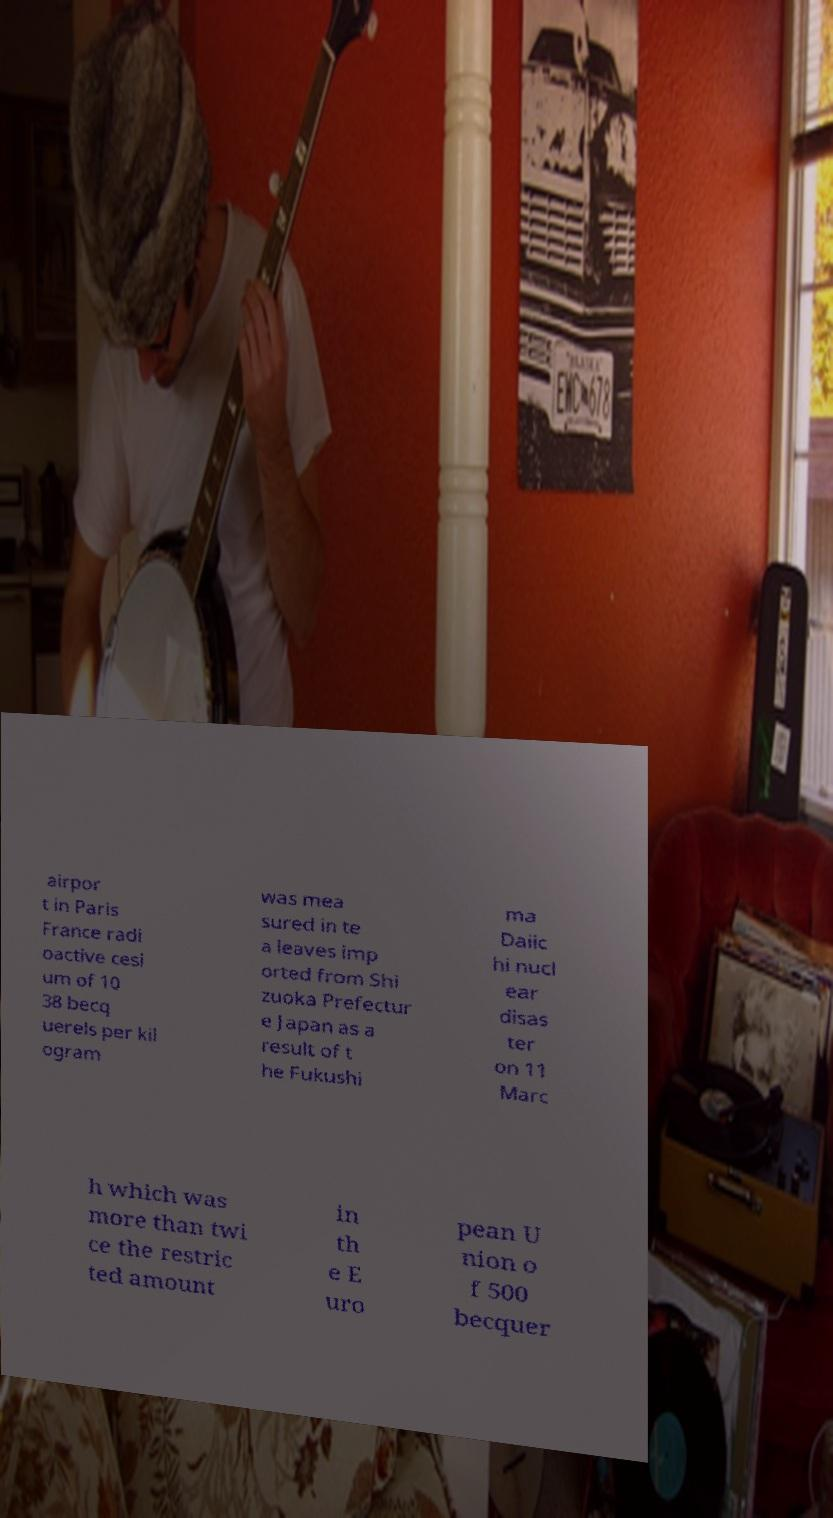Could you assist in decoding the text presented in this image and type it out clearly? airpor t in Paris France radi oactive cesi um of 10 38 becq uerels per kil ogram was mea sured in te a leaves imp orted from Shi zuoka Prefectur e Japan as a result of t he Fukushi ma Daiic hi nucl ear disas ter on 11 Marc h which was more than twi ce the restric ted amount in th e E uro pean U nion o f 500 becquer 